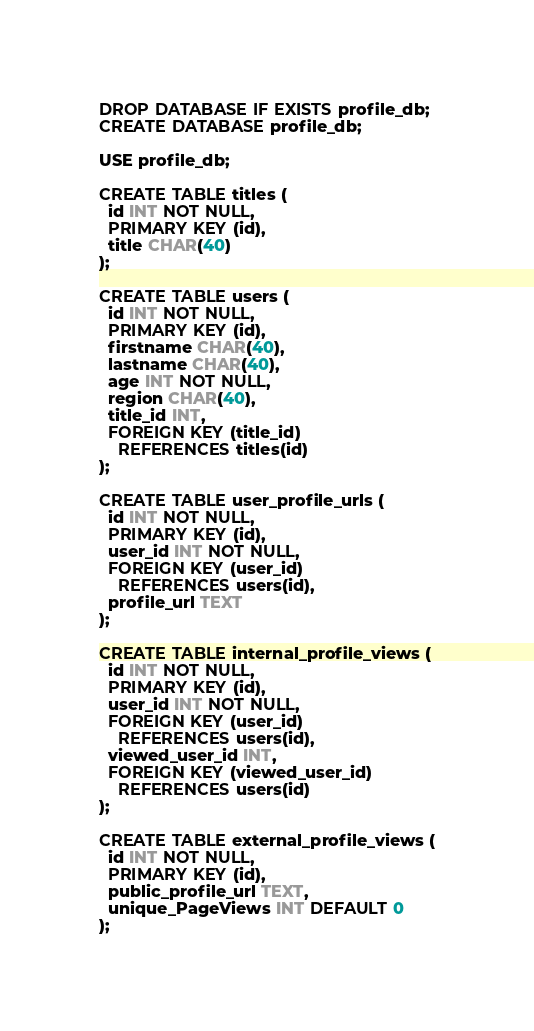Convert code to text. <code><loc_0><loc_0><loc_500><loc_500><_SQL_>DROP DATABASE IF EXISTS profile_db;
CREATE DATABASE profile_db;

USE profile_db;

CREATE TABLE titles (
  id INT NOT NULL,
  PRIMARY KEY (id),
  title CHAR(40)
);

CREATE TABLE users (
  id INT NOT NULL,
  PRIMARY KEY (id),
  firstname CHAR(40),
  lastname CHAR(40),
  age INT NOT NULL,
  region CHAR(40),
  title_id INT,
  FOREIGN KEY (title_id)
    REFERENCES titles(id)
);

CREATE TABLE user_profile_urls (
  id INT NOT NULL,
  PRIMARY KEY (id),
  user_id INT NOT NULL,
  FOREIGN KEY (user_id)
    REFERENCES users(id),
  profile_url TEXT
);

CREATE TABLE internal_profile_views (
  id INT NOT NULL,
  PRIMARY KEY (id),
  user_id INT NOT NULL,
  FOREIGN KEY (user_id)
    REFERENCES users(id),
  viewed_user_id INT,
  FOREIGN KEY (viewed_user_id)
    REFERENCES users(id)
);

CREATE TABLE external_profile_views (
  id INT NOT NULL,
  PRIMARY KEY (id),
  public_profile_url TEXT,
  unique_PageViews INT DEFAULT 0
);

</code> 